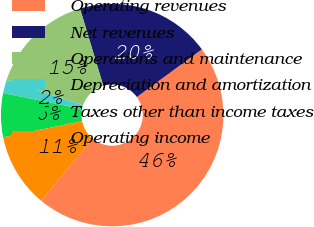Convert chart. <chart><loc_0><loc_0><loc_500><loc_500><pie_chart><fcel>Operating revenues<fcel>Net revenues<fcel>Operations and maintenance<fcel>Depreciation and amortization<fcel>Taxes other than income taxes<fcel>Operating income<nl><fcel>46.07%<fcel>19.61%<fcel>15.2%<fcel>1.96%<fcel>6.38%<fcel>10.79%<nl></chart> 